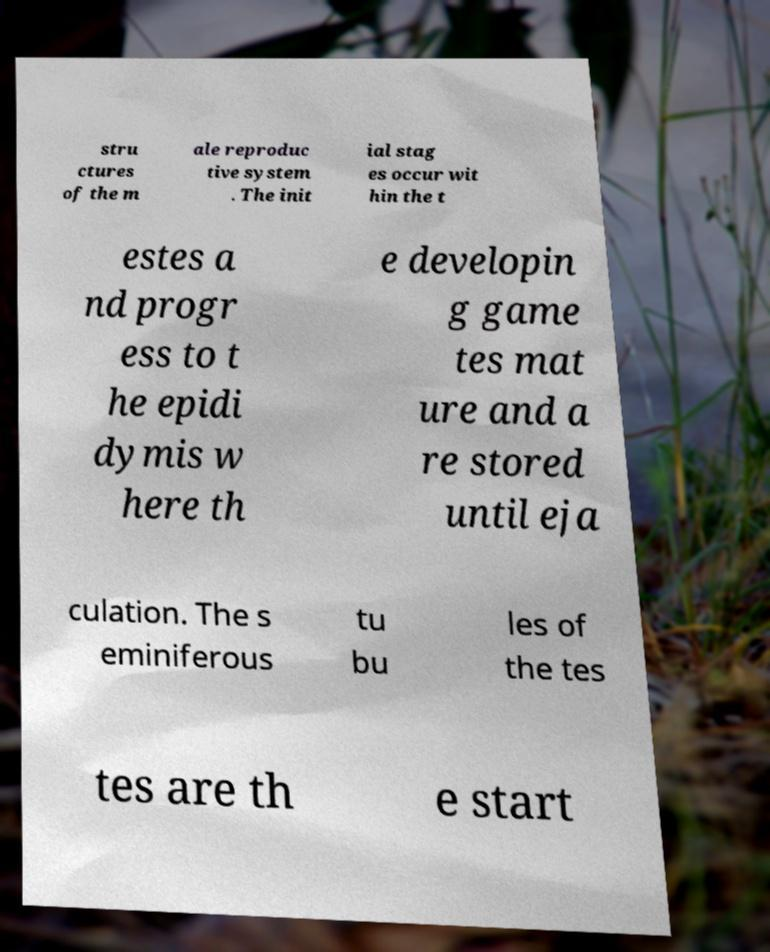I need the written content from this picture converted into text. Can you do that? stru ctures of the m ale reproduc tive system . The init ial stag es occur wit hin the t estes a nd progr ess to t he epidi dymis w here th e developin g game tes mat ure and a re stored until eja culation. The s eminiferous tu bu les of the tes tes are th e start 